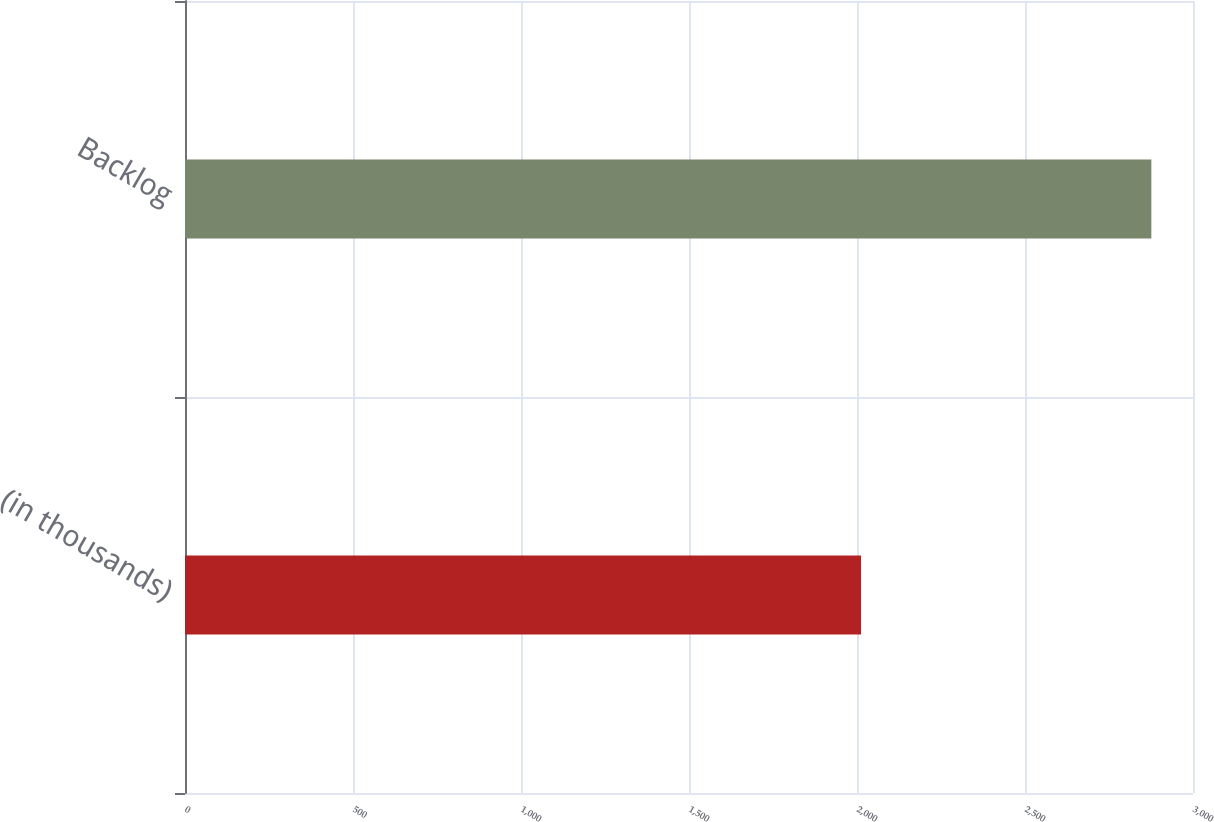Convert chart to OTSL. <chart><loc_0><loc_0><loc_500><loc_500><bar_chart><fcel>(in thousands)<fcel>Backlog<nl><fcel>2012<fcel>2876<nl></chart> 